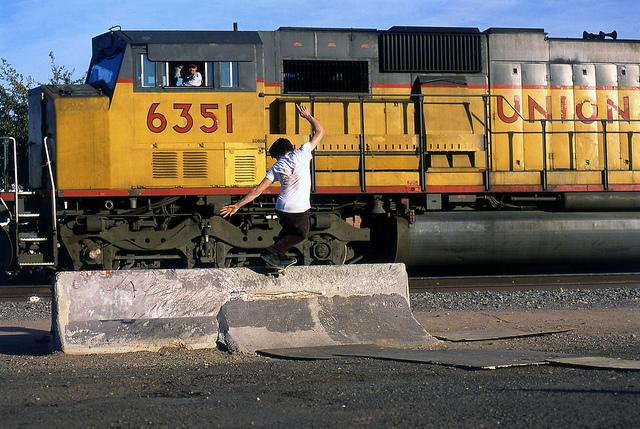Which direction did the skater just come from? left 